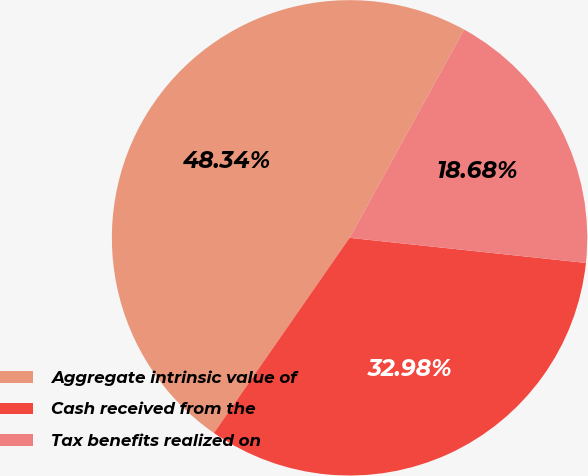Convert chart to OTSL. <chart><loc_0><loc_0><loc_500><loc_500><pie_chart><fcel>Aggregate intrinsic value of<fcel>Cash received from the<fcel>Tax benefits realized on<nl><fcel>48.34%<fcel>32.98%<fcel>18.68%<nl></chart> 